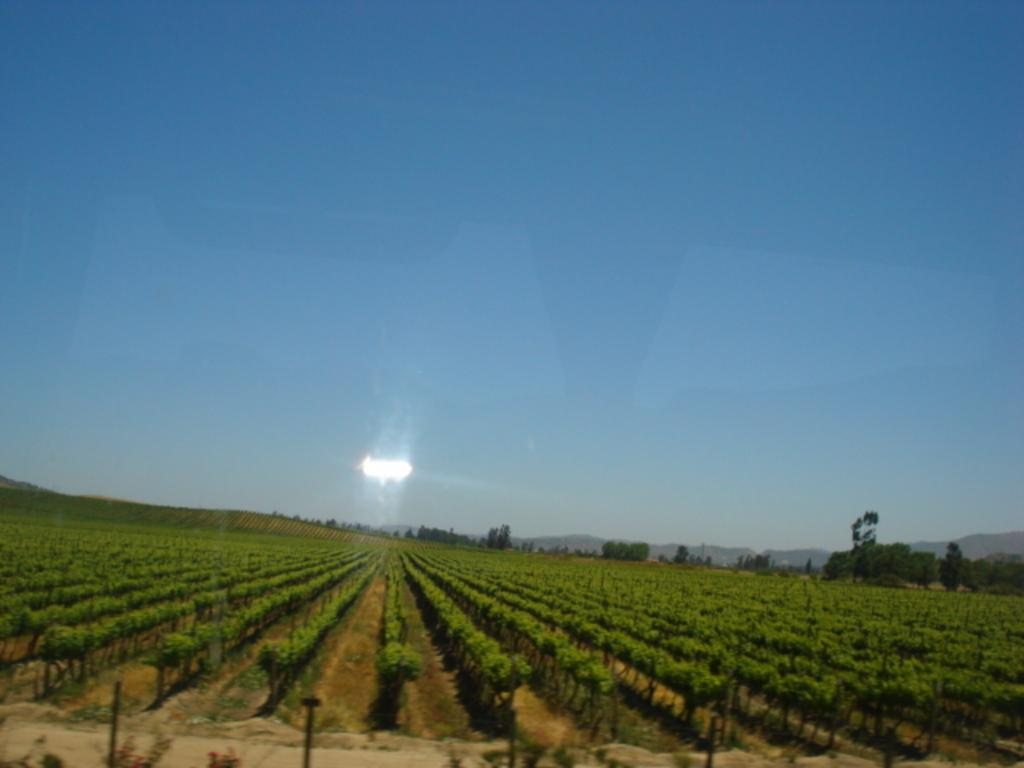What type of land is depicted in the image? The image shows agricultural land. What natural elements can be seen in the image? There are trees in the image. What is visible in the background of the image? The sky is visible in the background of the image. How many toes can be seen on the apples in the image? There are no apples or toes present in the image. What nation is represented by the agricultural land in the image? The image does not specify a nation; it only shows agricultural land. 